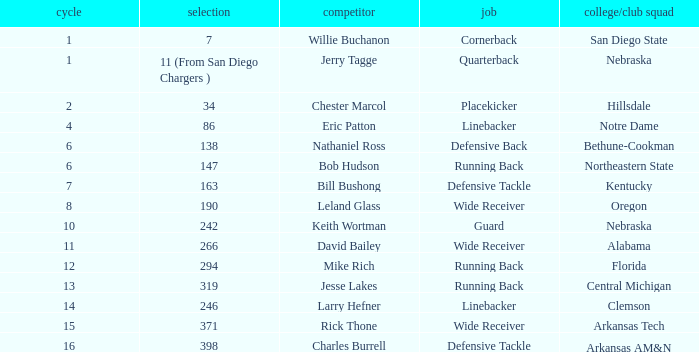In which round does the cornerback position occur? 1.0. 